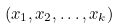Convert formula to latex. <formula><loc_0><loc_0><loc_500><loc_500>( x _ { 1 } , x _ { 2 } , \dots , x _ { k } )</formula> 